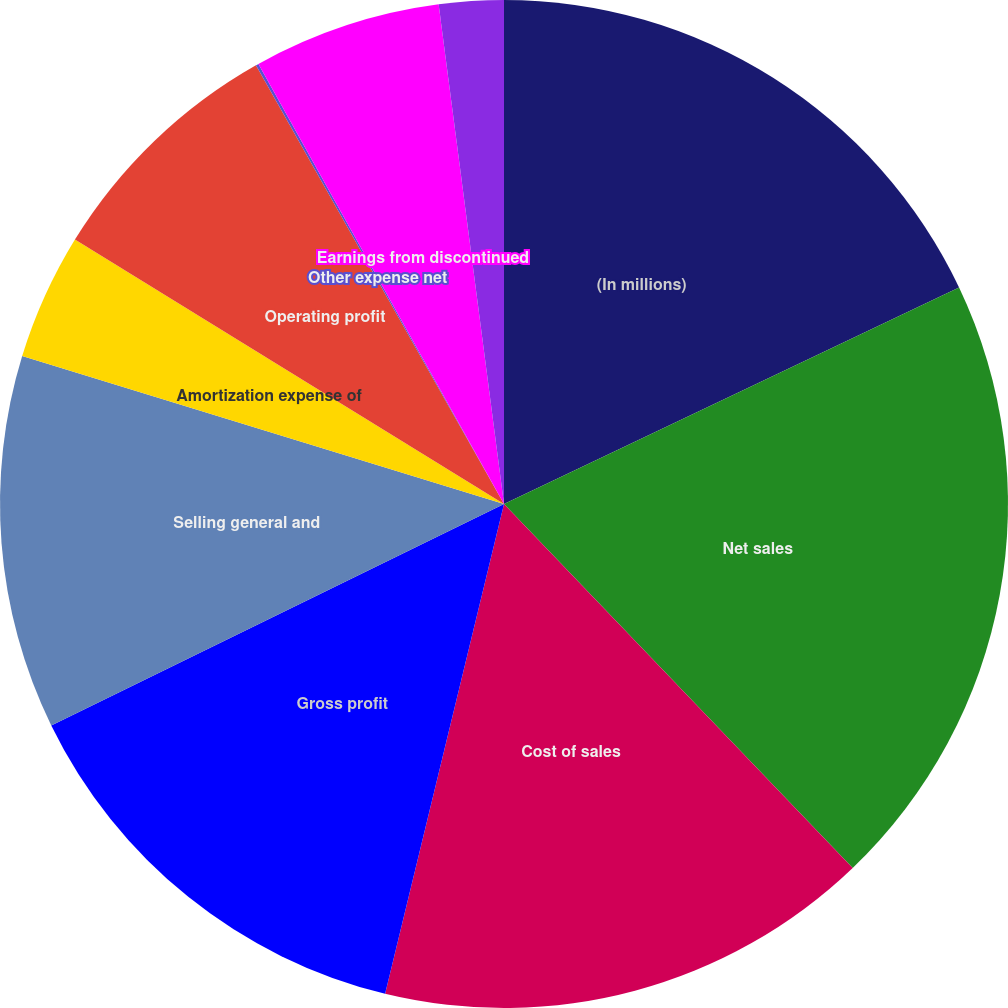Convert chart to OTSL. <chart><loc_0><loc_0><loc_500><loc_500><pie_chart><fcel>(In millions)<fcel>Net sales<fcel>Cost of sales<fcel>Gross profit<fcel>Selling general and<fcel>Amortization expense of<fcel>Operating profit<fcel>Other expense net<fcel>Earnings from discontinued<fcel>Income tax (benefit) provision<nl><fcel>17.93%<fcel>19.91%<fcel>15.95%<fcel>13.97%<fcel>11.98%<fcel>4.05%<fcel>8.02%<fcel>0.09%<fcel>6.03%<fcel>2.07%<nl></chart> 